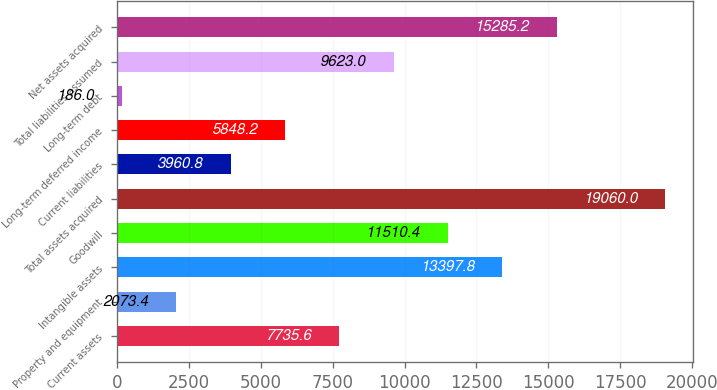Convert chart to OTSL. <chart><loc_0><loc_0><loc_500><loc_500><bar_chart><fcel>Current assets<fcel>Property and equipment<fcel>Intangible assets<fcel>Goodwill<fcel>Total assets acquired<fcel>Current liabilities<fcel>Long-term deferred income<fcel>Long-term debt<fcel>Total liabilities assumed<fcel>Net assets acquired<nl><fcel>7735.6<fcel>2073.4<fcel>13397.8<fcel>11510.4<fcel>19060<fcel>3960.8<fcel>5848.2<fcel>186<fcel>9623<fcel>15285.2<nl></chart> 